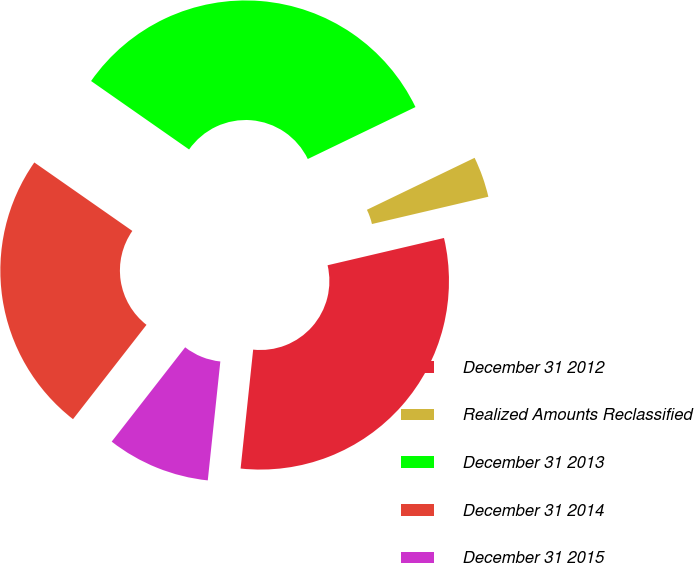Convert chart to OTSL. <chart><loc_0><loc_0><loc_500><loc_500><pie_chart><fcel>December 31 2012<fcel>Realized Amounts Reclassified<fcel>December 31 2013<fcel>December 31 2014<fcel>December 31 2015<nl><fcel>30.34%<fcel>3.49%<fcel>33.14%<fcel>24.17%<fcel>8.86%<nl></chart> 